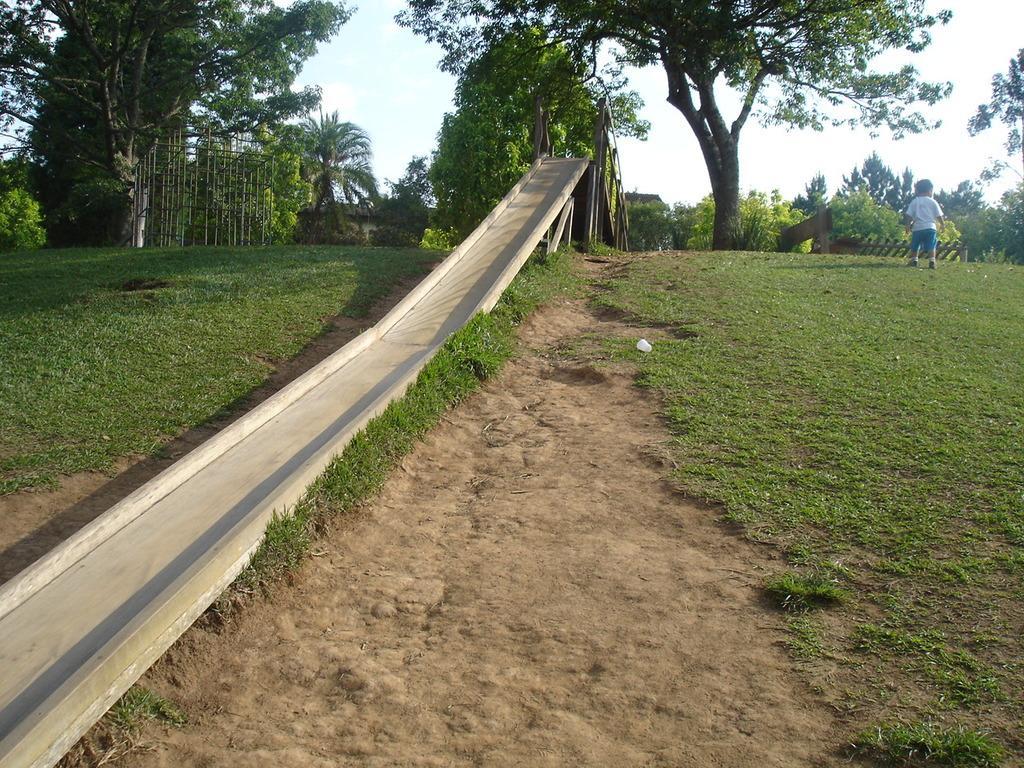In one or two sentences, can you explain what this image depicts? In this picture we can see a child on the grass, slide, trees, wooden objects and in the background we can see the sky. 